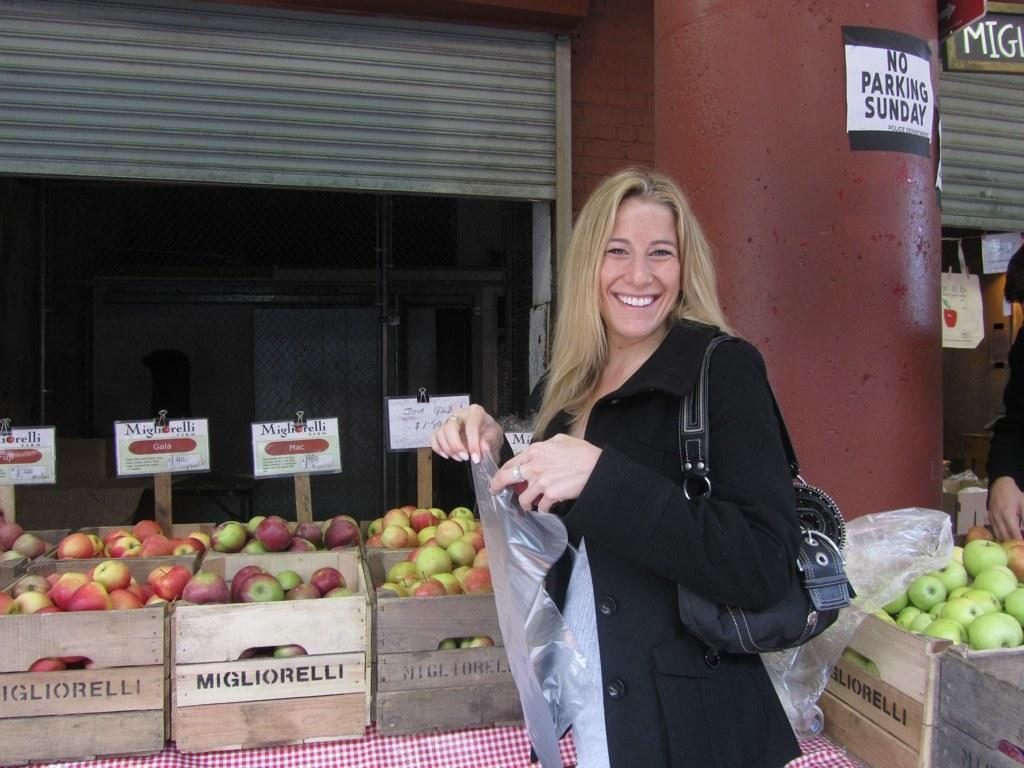Where was the image taken? The image was clicked outside. What can be seen in the image besides the person standing in the middle? There are fruits and shops visible in the image. What is the person holding in the image? The person is holding a cover. How many oranges are being held by the person in the image? There are no oranges visible in the image; only fruits in general are mentioned. What is the fifth item in the image? The provided facts do not mention a fifth item in the image. 